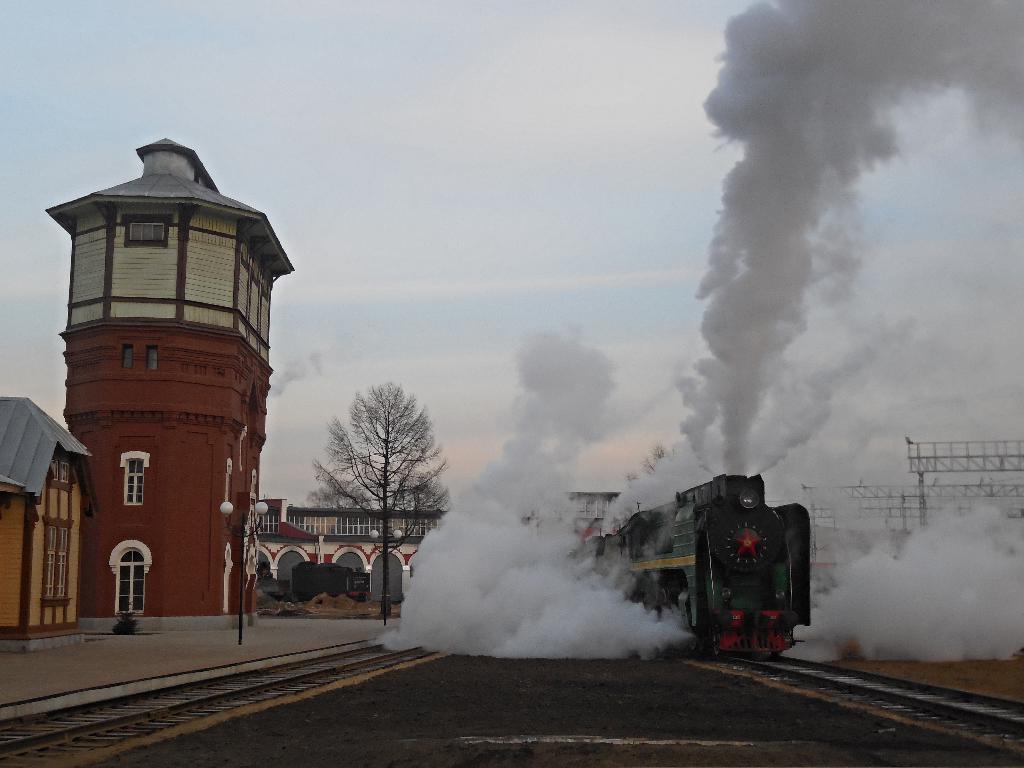In one or two sentences, can you explain what this image depicts? In the image there is a train releasing smoke moving on track on the right side, on the left side there are buildings with a tree in front of it and above its sky with clouds. 